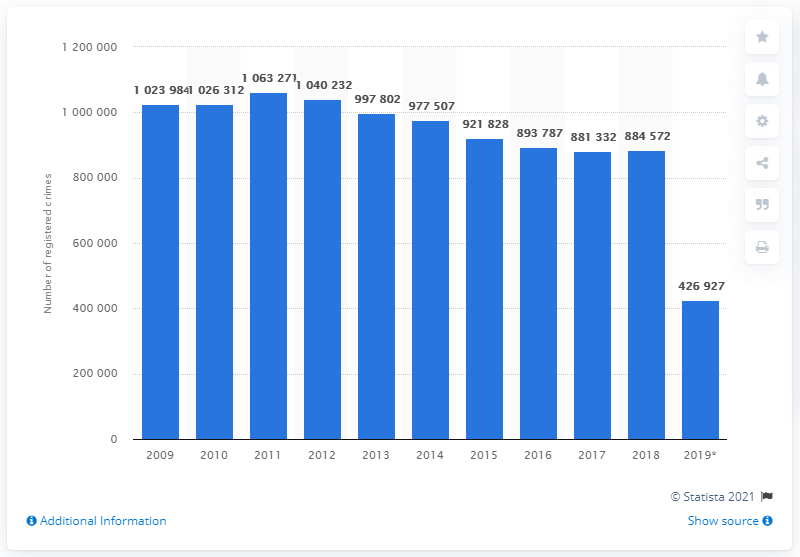Indicate a few pertinent items in this graphic. In 2011, a total of 1063271 crimes were registered. In the first semester of 2019, a total of 426,927 crimes were registered in Belgium. In 2018, the total number of registered crimes in Belgium was 884,572. 